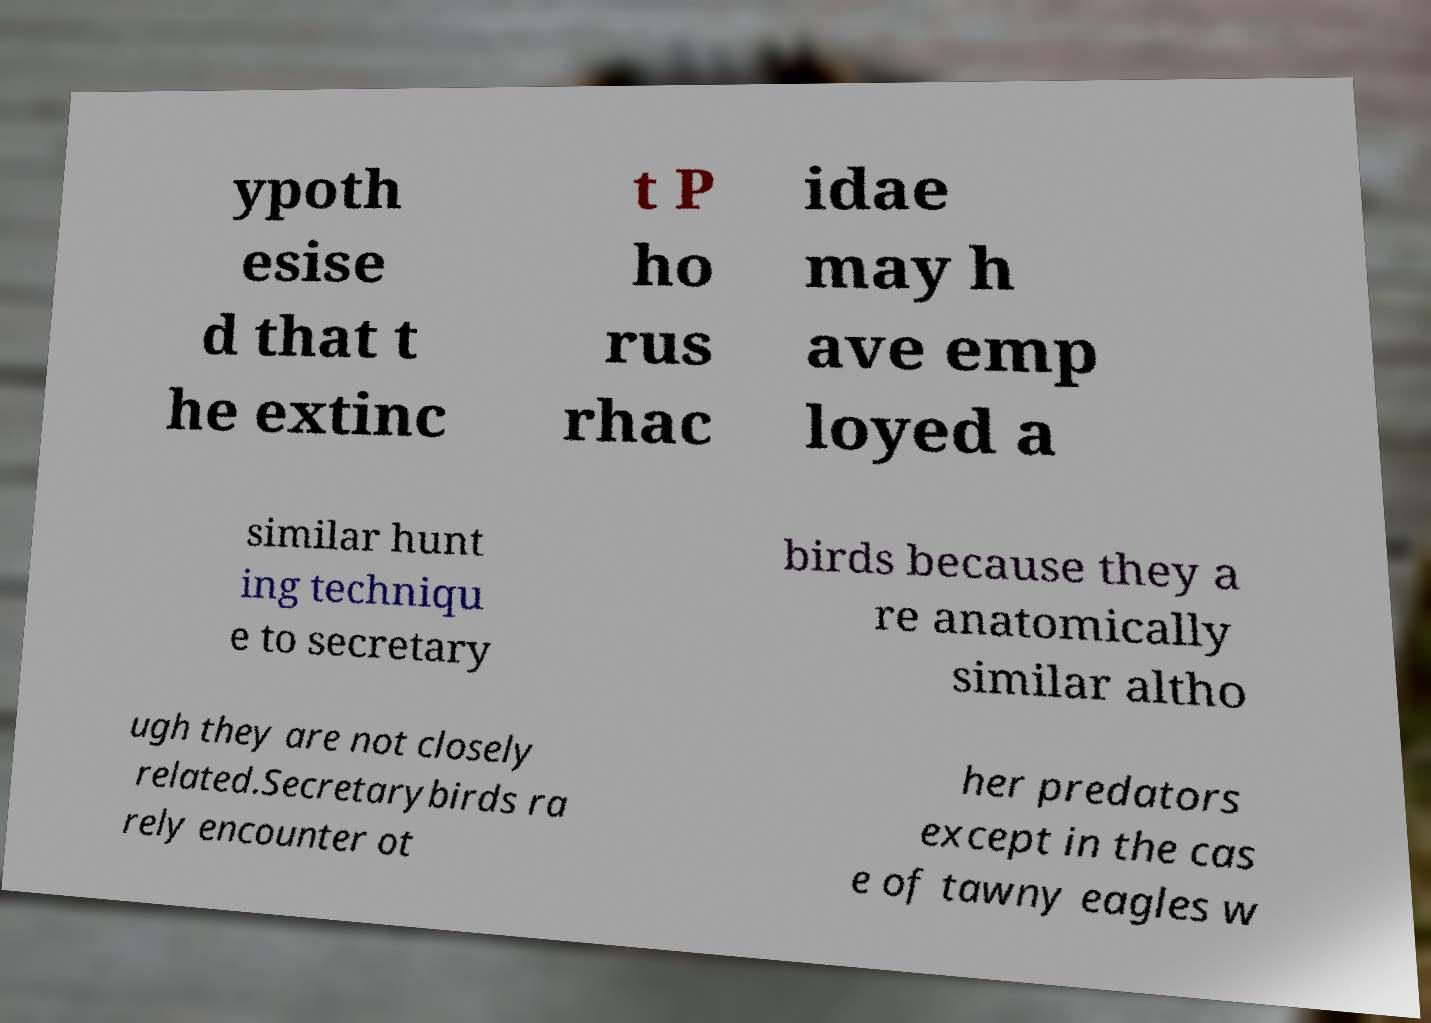I need the written content from this picture converted into text. Can you do that? ypoth esise d that t he extinc t P ho rus rhac idae may h ave emp loyed a similar hunt ing techniqu e to secretary birds because they a re anatomically similar altho ugh they are not closely related.Secretarybirds ra rely encounter ot her predators except in the cas e of tawny eagles w 